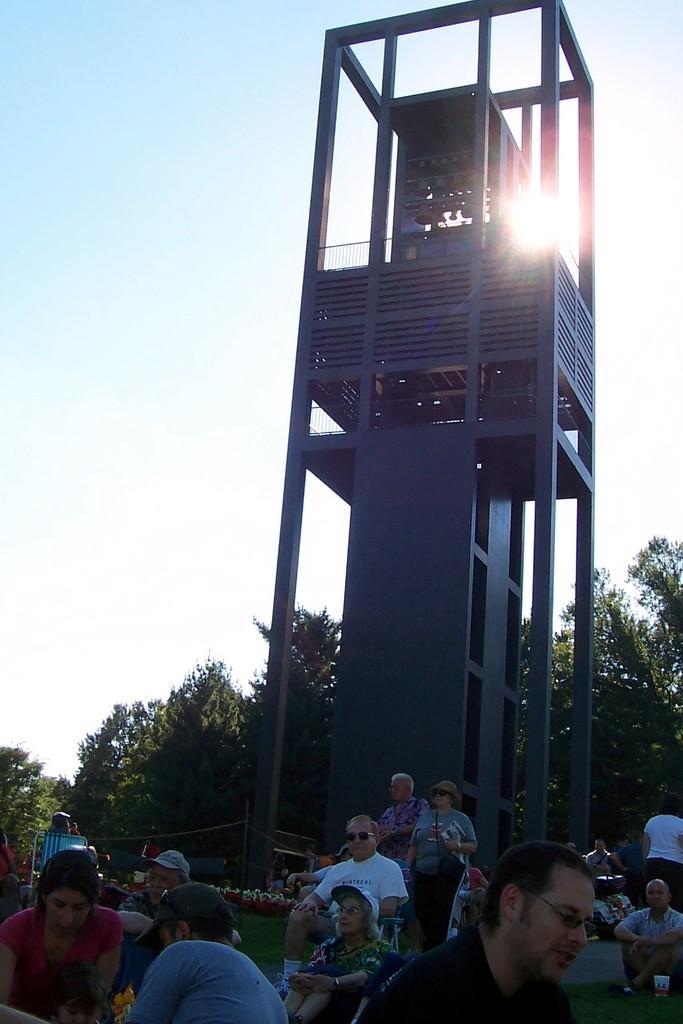Describe this image in one or two sentences. In the foreground of this picture, there is a carillon and in front to it there are persons sitting on the grass. In the background, there are trees, sky and the sun. 